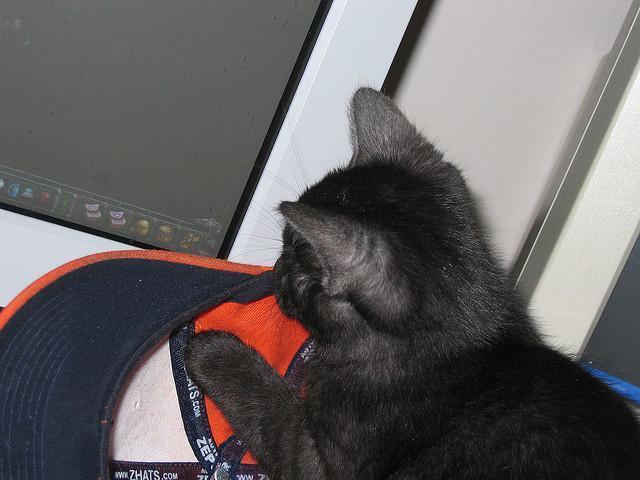How many people are on the white yacht?
Give a very brief answer. 0. 